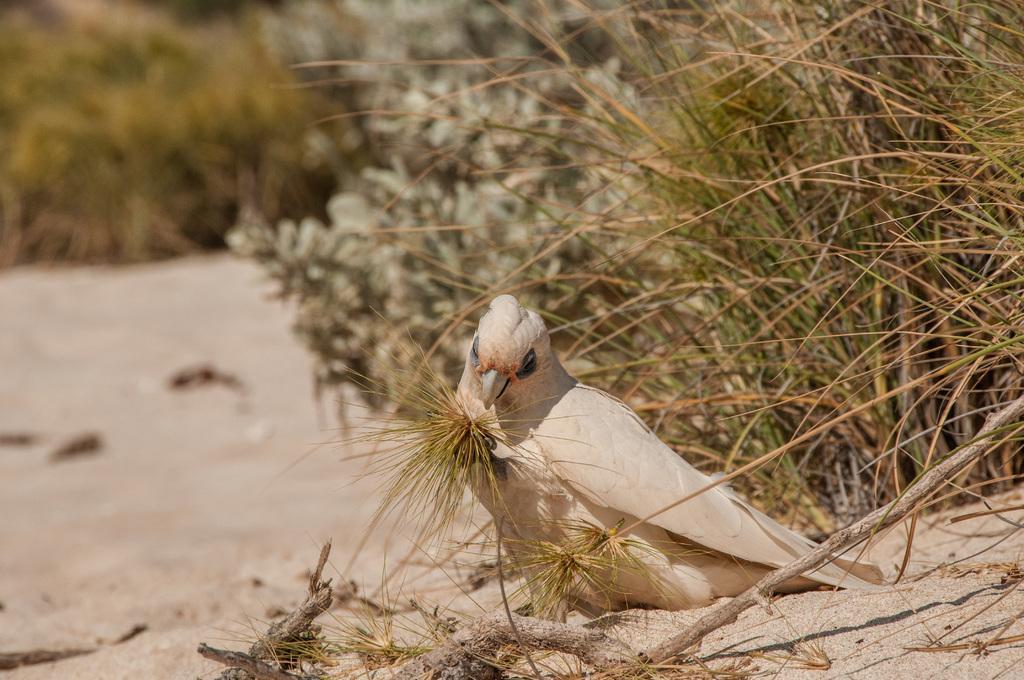Could you give a brief overview of what you see in this image? In this image I can see a bird sitting on the sand. The bird is in cream and white color. In the back I can see many trees and it is blurry. 